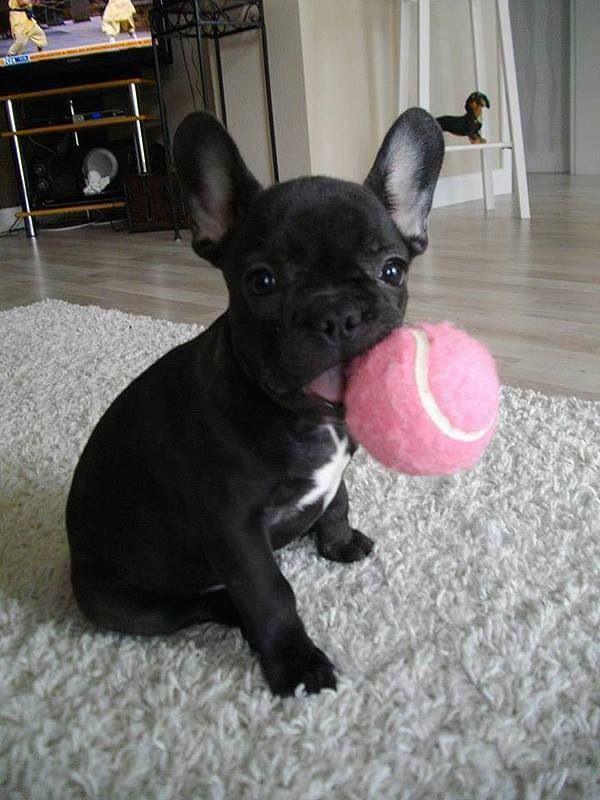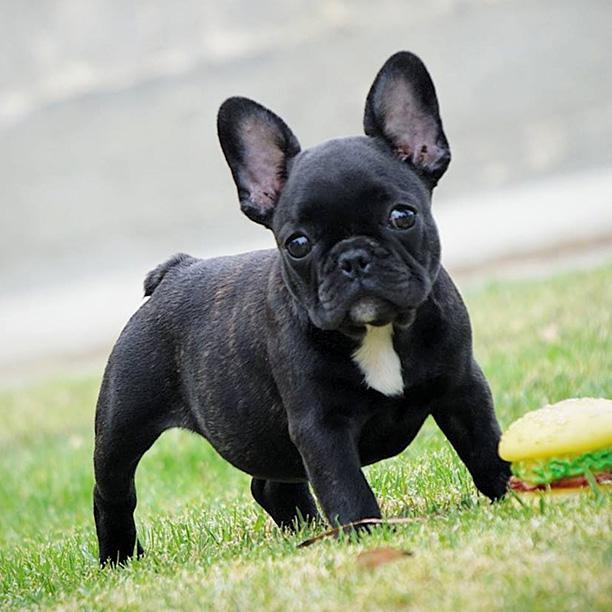The first image is the image on the left, the second image is the image on the right. For the images displayed, is the sentence "An image shows a black dog with some type of toy in the side of its mouth." factually correct? Answer yes or no. Yes. The first image is the image on the left, the second image is the image on the right. Analyze the images presented: Is the assertion "The single dog in each image is indoors." valid? Answer yes or no. No. 